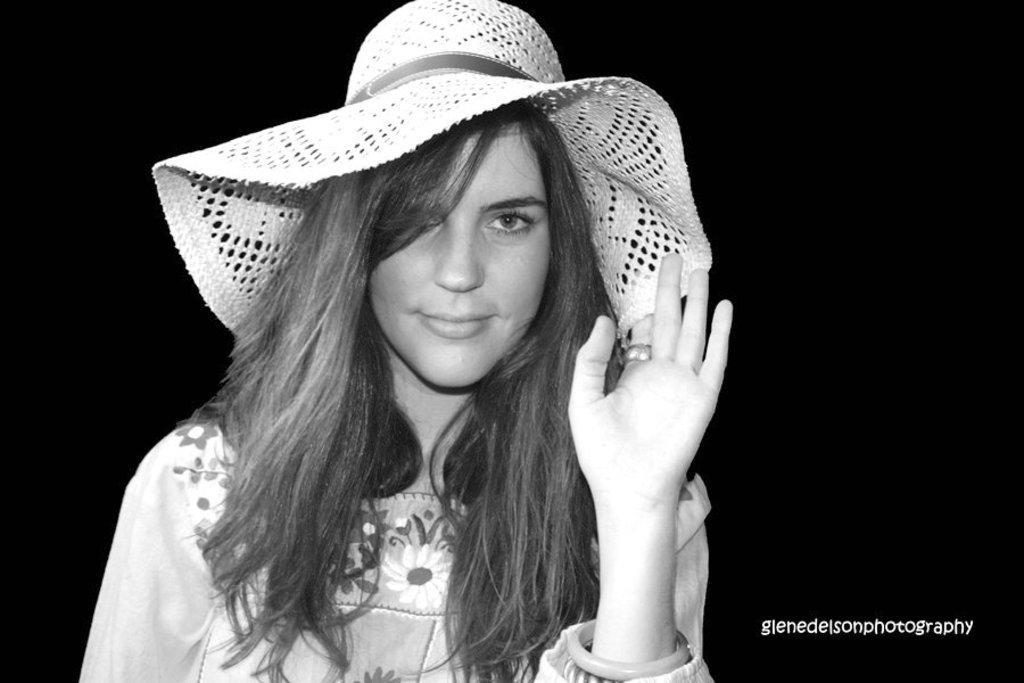Can you describe this image briefly? This image consists of a woman wearing a hat. The background is too dark. It looks like a black and white image. 